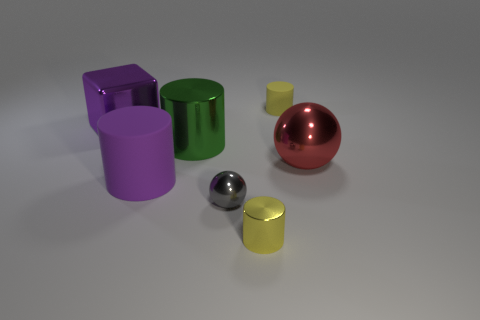Imagine these objects were part of a game. What kind of game could it be? These objects could be part of a physics puzzle game where players must arrange the objects to achieve balance or complete a challenge, taking advantage of their shapes and the physics properties of the simulated materials. 